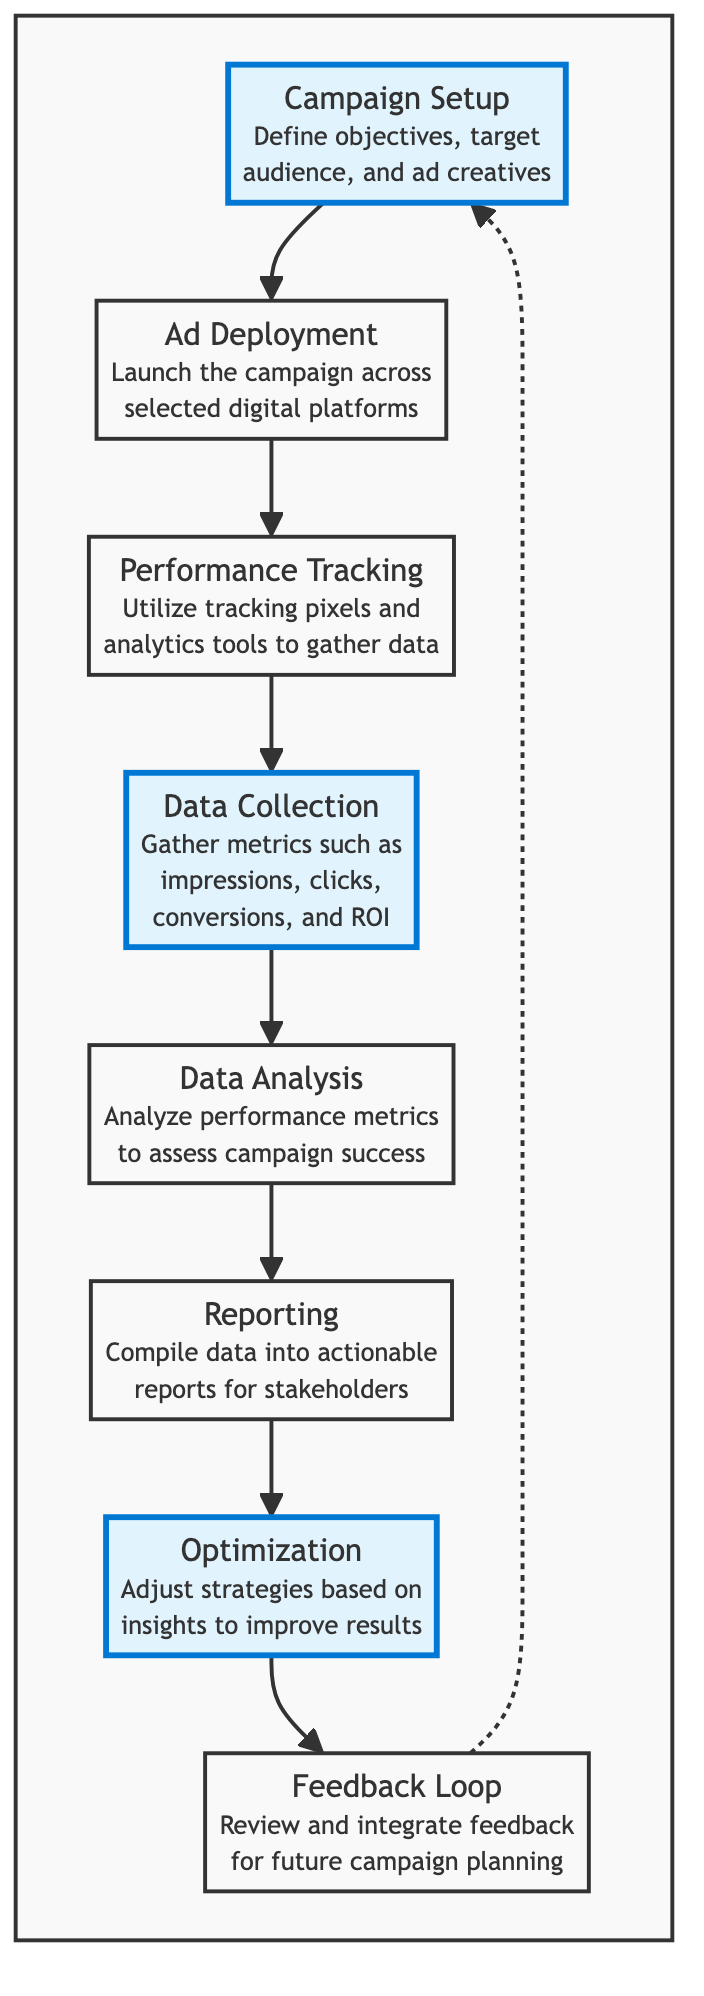What is the first step in the workflow? The workflow starts with "Campaign Setup," where objectives, target audience, and ad creatives are defined.
Answer: Campaign Setup How many steps are there in the workflow? Counting all the defined processes in the flowchart reveals a total of 8 steps.
Answer: 8 Which step comes after "Performance Tracking"? According to the flow of the diagram, the "Data Collection" step directly follows "Performance Tracking."
Answer: Data Collection What is the purpose of the "Reporting" step? The "Reporting" step compiles data into actionable reports for stakeholders to review campaign performance.
Answer: Compile data into actionable reports Which step leads back to the initial "Campaign Setup"? The "Feedback Loop" step points back to the "Campaign Setup," indicating that feedback is integrated for future campaigns.
Answer: Feedback Loop What is the last step in the workflow? The last step, as indicated by the flow diagram, is "Feedback Loop," which completes the cycle of performance evaluation.
Answer: Feedback Loop Which steps in the workflow are highlighted? The highlighted steps in the diagram are "Campaign Setup," "Data Collection," and "Optimization."
Answer: Campaign Setup, Data Collection, Optimization What is the relationship between "Optimization" and "Feedback Loop"? "Optimization" directly leads into "Feedback Loop," suggesting that insights from optimization inform the feedback process for future campaigns.
Answer: Optimization leads to Feedback Loop 